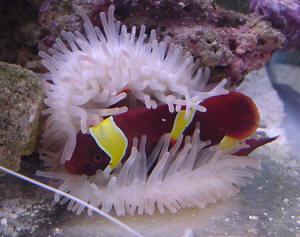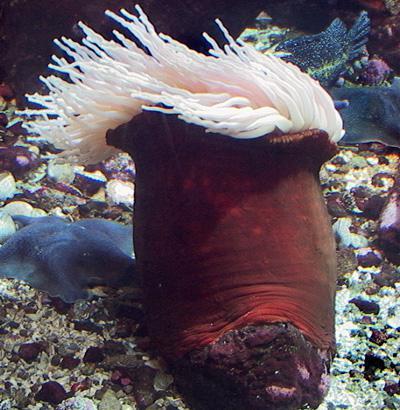The first image is the image on the left, the second image is the image on the right. For the images shown, is this caption "In at least one image there is at least one striped fish  swimming in corral." true? Answer yes or no. Yes. The first image is the image on the left, the second image is the image on the right. For the images displayed, is the sentence "At least one fish with bold stripes is positioned over the tendrils of an anemone in the left image." factually correct? Answer yes or no. Yes. 